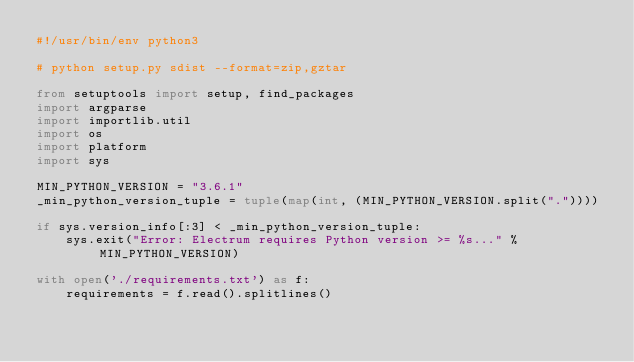Convert code to text. <code><loc_0><loc_0><loc_500><loc_500><_Python_>#!/usr/bin/env python3

# python setup.py sdist --format=zip,gztar

from setuptools import setup, find_packages
import argparse
import importlib.util
import os
import platform
import sys

MIN_PYTHON_VERSION = "3.6.1"
_min_python_version_tuple = tuple(map(int, (MIN_PYTHON_VERSION.split("."))))

if sys.version_info[:3] < _min_python_version_tuple:
    sys.exit("Error: Electrum requires Python version >= %s..." % MIN_PYTHON_VERSION)

with open('./requirements.txt') as f:
    requirements = f.read().splitlines()
</code> 